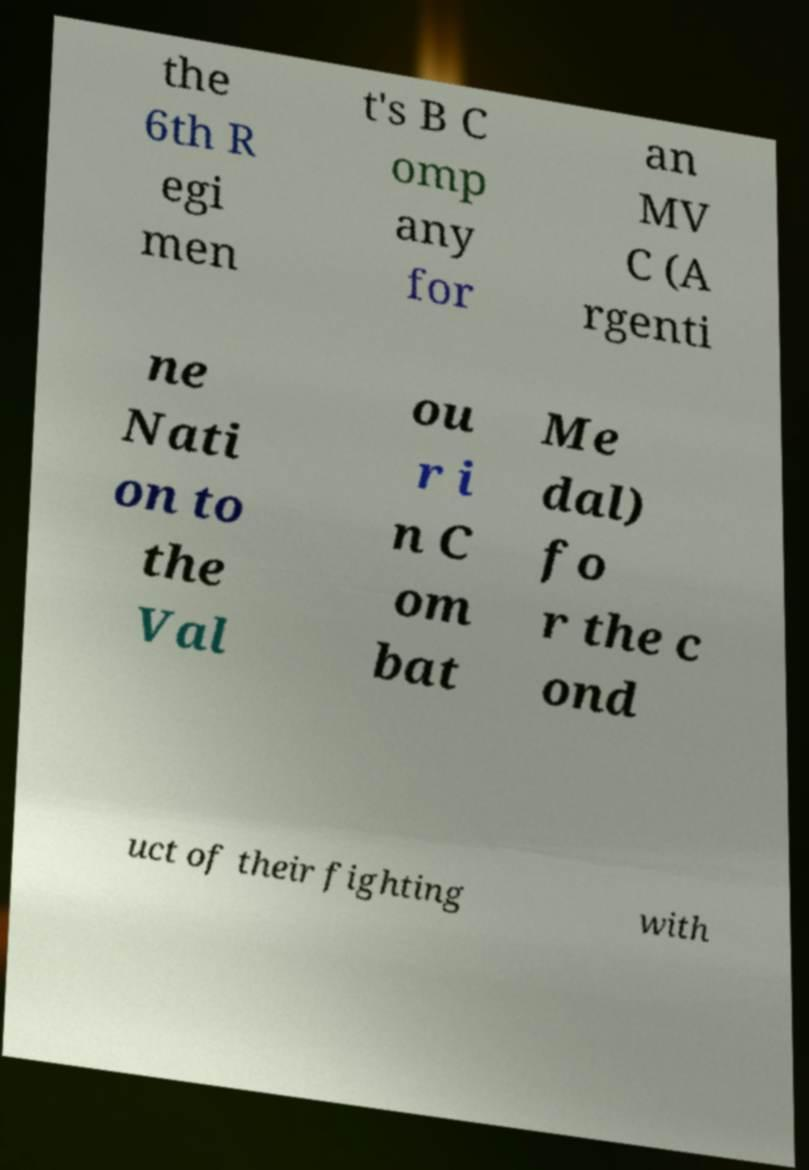There's text embedded in this image that I need extracted. Can you transcribe it verbatim? the 6th R egi men t's B C omp any for an MV C (A rgenti ne Nati on to the Val ou r i n C om bat Me dal) fo r the c ond uct of their fighting with 